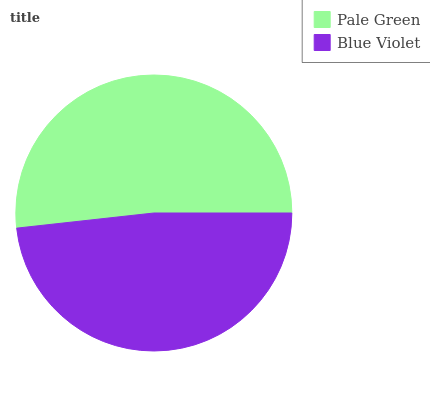Is Blue Violet the minimum?
Answer yes or no. Yes. Is Pale Green the maximum?
Answer yes or no. Yes. Is Blue Violet the maximum?
Answer yes or no. No. Is Pale Green greater than Blue Violet?
Answer yes or no. Yes. Is Blue Violet less than Pale Green?
Answer yes or no. Yes. Is Blue Violet greater than Pale Green?
Answer yes or no. No. Is Pale Green less than Blue Violet?
Answer yes or no. No. Is Pale Green the high median?
Answer yes or no. Yes. Is Blue Violet the low median?
Answer yes or no. Yes. Is Blue Violet the high median?
Answer yes or no. No. Is Pale Green the low median?
Answer yes or no. No. 